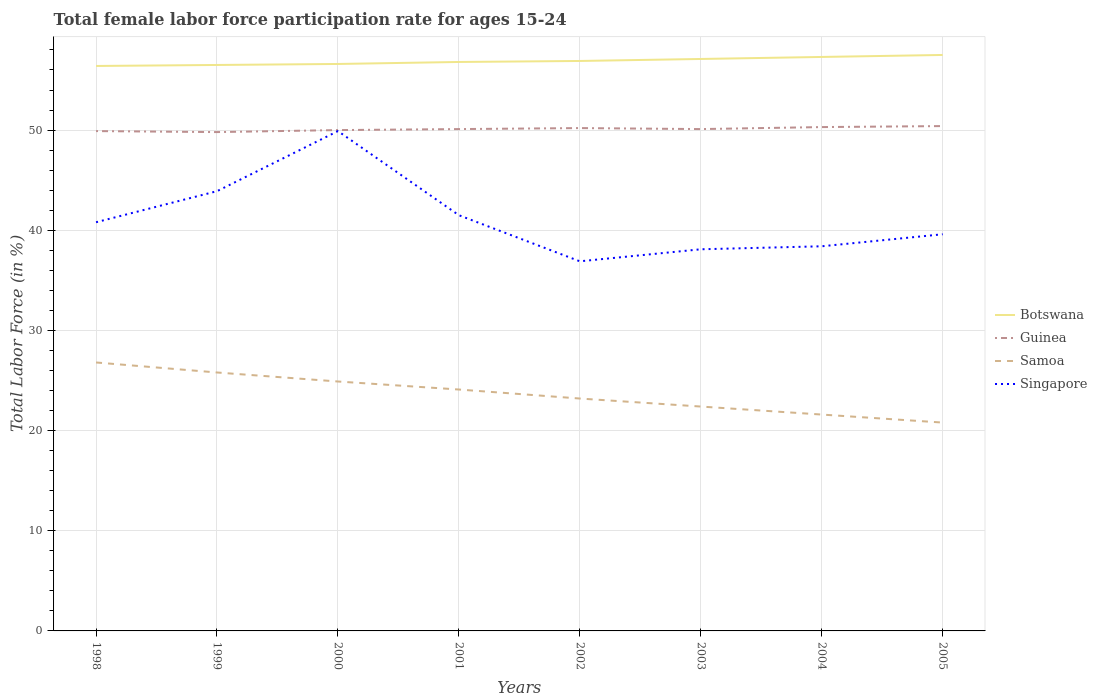Across all years, what is the maximum female labor force participation rate in Guinea?
Your answer should be very brief. 49.8. In which year was the female labor force participation rate in Singapore maximum?
Ensure brevity in your answer.  2002. What is the total female labor force participation rate in Samoa in the graph?
Keep it short and to the point. 2.7. What is the difference between the highest and the second highest female labor force participation rate in Singapore?
Ensure brevity in your answer.  13. What is the difference between the highest and the lowest female labor force participation rate in Guinea?
Keep it short and to the point. 3. Is the female labor force participation rate in Samoa strictly greater than the female labor force participation rate in Botswana over the years?
Provide a succinct answer. Yes. How many lines are there?
Provide a succinct answer. 4. How many years are there in the graph?
Ensure brevity in your answer.  8. Does the graph contain any zero values?
Offer a very short reply. No. Does the graph contain grids?
Give a very brief answer. Yes. What is the title of the graph?
Make the answer very short. Total female labor force participation rate for ages 15-24. What is the Total Labor Force (in %) of Botswana in 1998?
Your answer should be compact. 56.4. What is the Total Labor Force (in %) of Guinea in 1998?
Keep it short and to the point. 49.9. What is the Total Labor Force (in %) in Samoa in 1998?
Your answer should be compact. 26.8. What is the Total Labor Force (in %) in Singapore in 1998?
Offer a very short reply. 40.8. What is the Total Labor Force (in %) of Botswana in 1999?
Provide a short and direct response. 56.5. What is the Total Labor Force (in %) in Guinea in 1999?
Give a very brief answer. 49.8. What is the Total Labor Force (in %) in Samoa in 1999?
Keep it short and to the point. 25.8. What is the Total Labor Force (in %) of Singapore in 1999?
Provide a succinct answer. 43.9. What is the Total Labor Force (in %) in Botswana in 2000?
Provide a short and direct response. 56.6. What is the Total Labor Force (in %) of Samoa in 2000?
Your answer should be compact. 24.9. What is the Total Labor Force (in %) of Singapore in 2000?
Give a very brief answer. 49.9. What is the Total Labor Force (in %) of Botswana in 2001?
Ensure brevity in your answer.  56.8. What is the Total Labor Force (in %) in Guinea in 2001?
Keep it short and to the point. 50.1. What is the Total Labor Force (in %) in Samoa in 2001?
Your answer should be very brief. 24.1. What is the Total Labor Force (in %) in Singapore in 2001?
Make the answer very short. 41.5. What is the Total Labor Force (in %) in Botswana in 2002?
Provide a succinct answer. 56.9. What is the Total Labor Force (in %) of Guinea in 2002?
Your answer should be very brief. 50.2. What is the Total Labor Force (in %) of Samoa in 2002?
Provide a short and direct response. 23.2. What is the Total Labor Force (in %) in Singapore in 2002?
Provide a short and direct response. 36.9. What is the Total Labor Force (in %) of Botswana in 2003?
Offer a terse response. 57.1. What is the Total Labor Force (in %) in Guinea in 2003?
Your response must be concise. 50.1. What is the Total Labor Force (in %) in Samoa in 2003?
Offer a very short reply. 22.4. What is the Total Labor Force (in %) in Singapore in 2003?
Provide a short and direct response. 38.1. What is the Total Labor Force (in %) in Botswana in 2004?
Keep it short and to the point. 57.3. What is the Total Labor Force (in %) in Guinea in 2004?
Offer a very short reply. 50.3. What is the Total Labor Force (in %) in Samoa in 2004?
Ensure brevity in your answer.  21.6. What is the Total Labor Force (in %) in Singapore in 2004?
Your response must be concise. 38.4. What is the Total Labor Force (in %) of Botswana in 2005?
Your answer should be very brief. 57.5. What is the Total Labor Force (in %) in Guinea in 2005?
Offer a terse response. 50.4. What is the Total Labor Force (in %) of Samoa in 2005?
Offer a very short reply. 20.8. What is the Total Labor Force (in %) of Singapore in 2005?
Keep it short and to the point. 39.6. Across all years, what is the maximum Total Labor Force (in %) of Botswana?
Your answer should be very brief. 57.5. Across all years, what is the maximum Total Labor Force (in %) in Guinea?
Offer a very short reply. 50.4. Across all years, what is the maximum Total Labor Force (in %) of Samoa?
Make the answer very short. 26.8. Across all years, what is the maximum Total Labor Force (in %) in Singapore?
Your answer should be very brief. 49.9. Across all years, what is the minimum Total Labor Force (in %) in Botswana?
Your answer should be compact. 56.4. Across all years, what is the minimum Total Labor Force (in %) of Guinea?
Make the answer very short. 49.8. Across all years, what is the minimum Total Labor Force (in %) in Samoa?
Offer a terse response. 20.8. Across all years, what is the minimum Total Labor Force (in %) in Singapore?
Offer a terse response. 36.9. What is the total Total Labor Force (in %) of Botswana in the graph?
Offer a very short reply. 455.1. What is the total Total Labor Force (in %) in Guinea in the graph?
Your response must be concise. 400.8. What is the total Total Labor Force (in %) in Samoa in the graph?
Provide a succinct answer. 189.6. What is the total Total Labor Force (in %) in Singapore in the graph?
Make the answer very short. 329.1. What is the difference between the Total Labor Force (in %) in Botswana in 1998 and that in 1999?
Make the answer very short. -0.1. What is the difference between the Total Labor Force (in %) of Guinea in 1998 and that in 1999?
Offer a terse response. 0.1. What is the difference between the Total Labor Force (in %) in Singapore in 1998 and that in 1999?
Provide a succinct answer. -3.1. What is the difference between the Total Labor Force (in %) of Botswana in 1998 and that in 2000?
Your answer should be compact. -0.2. What is the difference between the Total Labor Force (in %) in Guinea in 1998 and that in 2000?
Make the answer very short. -0.1. What is the difference between the Total Labor Force (in %) of Guinea in 1998 and that in 2002?
Give a very brief answer. -0.3. What is the difference between the Total Labor Force (in %) in Singapore in 1998 and that in 2002?
Your response must be concise. 3.9. What is the difference between the Total Labor Force (in %) in Samoa in 1998 and that in 2003?
Offer a terse response. 4.4. What is the difference between the Total Labor Force (in %) of Guinea in 1998 and that in 2004?
Ensure brevity in your answer.  -0.4. What is the difference between the Total Labor Force (in %) in Singapore in 1998 and that in 2004?
Offer a terse response. 2.4. What is the difference between the Total Labor Force (in %) in Guinea in 1998 and that in 2005?
Make the answer very short. -0.5. What is the difference between the Total Labor Force (in %) in Guinea in 1999 and that in 2000?
Give a very brief answer. -0.2. What is the difference between the Total Labor Force (in %) of Samoa in 1999 and that in 2000?
Provide a short and direct response. 0.9. What is the difference between the Total Labor Force (in %) in Singapore in 1999 and that in 2000?
Give a very brief answer. -6. What is the difference between the Total Labor Force (in %) in Samoa in 1999 and that in 2001?
Your answer should be compact. 1.7. What is the difference between the Total Labor Force (in %) of Singapore in 1999 and that in 2001?
Give a very brief answer. 2.4. What is the difference between the Total Labor Force (in %) of Botswana in 1999 and that in 2002?
Give a very brief answer. -0.4. What is the difference between the Total Labor Force (in %) of Samoa in 1999 and that in 2002?
Offer a terse response. 2.6. What is the difference between the Total Labor Force (in %) in Botswana in 1999 and that in 2003?
Make the answer very short. -0.6. What is the difference between the Total Labor Force (in %) in Singapore in 1999 and that in 2003?
Provide a short and direct response. 5.8. What is the difference between the Total Labor Force (in %) in Guinea in 1999 and that in 2004?
Your answer should be very brief. -0.5. What is the difference between the Total Labor Force (in %) in Singapore in 1999 and that in 2004?
Ensure brevity in your answer.  5.5. What is the difference between the Total Labor Force (in %) in Guinea in 1999 and that in 2005?
Your answer should be compact. -0.6. What is the difference between the Total Labor Force (in %) in Singapore in 1999 and that in 2005?
Make the answer very short. 4.3. What is the difference between the Total Labor Force (in %) in Samoa in 2000 and that in 2001?
Make the answer very short. 0.8. What is the difference between the Total Labor Force (in %) of Botswana in 2000 and that in 2002?
Provide a short and direct response. -0.3. What is the difference between the Total Labor Force (in %) in Singapore in 2000 and that in 2002?
Offer a terse response. 13. What is the difference between the Total Labor Force (in %) in Guinea in 2000 and that in 2003?
Ensure brevity in your answer.  -0.1. What is the difference between the Total Labor Force (in %) in Samoa in 2000 and that in 2003?
Ensure brevity in your answer.  2.5. What is the difference between the Total Labor Force (in %) in Samoa in 2000 and that in 2004?
Offer a terse response. 3.3. What is the difference between the Total Labor Force (in %) in Singapore in 2000 and that in 2004?
Give a very brief answer. 11.5. What is the difference between the Total Labor Force (in %) in Botswana in 2000 and that in 2005?
Your answer should be compact. -0.9. What is the difference between the Total Labor Force (in %) in Guinea in 2000 and that in 2005?
Ensure brevity in your answer.  -0.4. What is the difference between the Total Labor Force (in %) of Samoa in 2000 and that in 2005?
Keep it short and to the point. 4.1. What is the difference between the Total Labor Force (in %) of Singapore in 2000 and that in 2005?
Your answer should be compact. 10.3. What is the difference between the Total Labor Force (in %) of Botswana in 2001 and that in 2002?
Give a very brief answer. -0.1. What is the difference between the Total Labor Force (in %) in Guinea in 2001 and that in 2002?
Your response must be concise. -0.1. What is the difference between the Total Labor Force (in %) in Botswana in 2001 and that in 2003?
Provide a succinct answer. -0.3. What is the difference between the Total Labor Force (in %) in Singapore in 2001 and that in 2003?
Ensure brevity in your answer.  3.4. What is the difference between the Total Labor Force (in %) of Guinea in 2001 and that in 2004?
Keep it short and to the point. -0.2. What is the difference between the Total Labor Force (in %) of Singapore in 2001 and that in 2004?
Ensure brevity in your answer.  3.1. What is the difference between the Total Labor Force (in %) of Singapore in 2001 and that in 2005?
Provide a short and direct response. 1.9. What is the difference between the Total Labor Force (in %) in Botswana in 2002 and that in 2003?
Provide a short and direct response. -0.2. What is the difference between the Total Labor Force (in %) of Samoa in 2002 and that in 2003?
Your response must be concise. 0.8. What is the difference between the Total Labor Force (in %) in Botswana in 2002 and that in 2004?
Your response must be concise. -0.4. What is the difference between the Total Labor Force (in %) of Guinea in 2002 and that in 2004?
Keep it short and to the point. -0.1. What is the difference between the Total Labor Force (in %) of Samoa in 2002 and that in 2004?
Provide a short and direct response. 1.6. What is the difference between the Total Labor Force (in %) of Guinea in 2002 and that in 2005?
Offer a very short reply. -0.2. What is the difference between the Total Labor Force (in %) in Singapore in 2002 and that in 2005?
Your answer should be compact. -2.7. What is the difference between the Total Labor Force (in %) of Samoa in 2003 and that in 2005?
Provide a short and direct response. 1.6. What is the difference between the Total Labor Force (in %) of Botswana in 2004 and that in 2005?
Give a very brief answer. -0.2. What is the difference between the Total Labor Force (in %) in Samoa in 2004 and that in 2005?
Ensure brevity in your answer.  0.8. What is the difference between the Total Labor Force (in %) of Botswana in 1998 and the Total Labor Force (in %) of Samoa in 1999?
Provide a short and direct response. 30.6. What is the difference between the Total Labor Force (in %) in Guinea in 1998 and the Total Labor Force (in %) in Samoa in 1999?
Make the answer very short. 24.1. What is the difference between the Total Labor Force (in %) of Samoa in 1998 and the Total Labor Force (in %) of Singapore in 1999?
Make the answer very short. -17.1. What is the difference between the Total Labor Force (in %) in Botswana in 1998 and the Total Labor Force (in %) in Guinea in 2000?
Your answer should be compact. 6.4. What is the difference between the Total Labor Force (in %) in Botswana in 1998 and the Total Labor Force (in %) in Samoa in 2000?
Your response must be concise. 31.5. What is the difference between the Total Labor Force (in %) of Botswana in 1998 and the Total Labor Force (in %) of Singapore in 2000?
Offer a very short reply. 6.5. What is the difference between the Total Labor Force (in %) in Guinea in 1998 and the Total Labor Force (in %) in Samoa in 2000?
Make the answer very short. 25. What is the difference between the Total Labor Force (in %) of Guinea in 1998 and the Total Labor Force (in %) of Singapore in 2000?
Ensure brevity in your answer.  0. What is the difference between the Total Labor Force (in %) of Samoa in 1998 and the Total Labor Force (in %) of Singapore in 2000?
Your response must be concise. -23.1. What is the difference between the Total Labor Force (in %) of Botswana in 1998 and the Total Labor Force (in %) of Samoa in 2001?
Keep it short and to the point. 32.3. What is the difference between the Total Labor Force (in %) in Botswana in 1998 and the Total Labor Force (in %) in Singapore in 2001?
Give a very brief answer. 14.9. What is the difference between the Total Labor Force (in %) in Guinea in 1998 and the Total Labor Force (in %) in Samoa in 2001?
Your answer should be very brief. 25.8. What is the difference between the Total Labor Force (in %) of Guinea in 1998 and the Total Labor Force (in %) of Singapore in 2001?
Provide a short and direct response. 8.4. What is the difference between the Total Labor Force (in %) of Samoa in 1998 and the Total Labor Force (in %) of Singapore in 2001?
Your answer should be very brief. -14.7. What is the difference between the Total Labor Force (in %) of Botswana in 1998 and the Total Labor Force (in %) of Samoa in 2002?
Ensure brevity in your answer.  33.2. What is the difference between the Total Labor Force (in %) of Guinea in 1998 and the Total Labor Force (in %) of Samoa in 2002?
Your answer should be very brief. 26.7. What is the difference between the Total Labor Force (in %) of Guinea in 1998 and the Total Labor Force (in %) of Singapore in 2002?
Keep it short and to the point. 13. What is the difference between the Total Labor Force (in %) in Samoa in 1998 and the Total Labor Force (in %) in Singapore in 2002?
Offer a terse response. -10.1. What is the difference between the Total Labor Force (in %) in Botswana in 1998 and the Total Labor Force (in %) in Guinea in 2003?
Keep it short and to the point. 6.3. What is the difference between the Total Labor Force (in %) in Botswana in 1998 and the Total Labor Force (in %) in Samoa in 2003?
Provide a short and direct response. 34. What is the difference between the Total Labor Force (in %) in Guinea in 1998 and the Total Labor Force (in %) in Samoa in 2003?
Your answer should be compact. 27.5. What is the difference between the Total Labor Force (in %) in Guinea in 1998 and the Total Labor Force (in %) in Singapore in 2003?
Ensure brevity in your answer.  11.8. What is the difference between the Total Labor Force (in %) in Samoa in 1998 and the Total Labor Force (in %) in Singapore in 2003?
Offer a terse response. -11.3. What is the difference between the Total Labor Force (in %) in Botswana in 1998 and the Total Labor Force (in %) in Samoa in 2004?
Your answer should be compact. 34.8. What is the difference between the Total Labor Force (in %) of Guinea in 1998 and the Total Labor Force (in %) of Samoa in 2004?
Provide a succinct answer. 28.3. What is the difference between the Total Labor Force (in %) of Guinea in 1998 and the Total Labor Force (in %) of Singapore in 2004?
Your answer should be very brief. 11.5. What is the difference between the Total Labor Force (in %) of Botswana in 1998 and the Total Labor Force (in %) of Guinea in 2005?
Ensure brevity in your answer.  6. What is the difference between the Total Labor Force (in %) in Botswana in 1998 and the Total Labor Force (in %) in Samoa in 2005?
Keep it short and to the point. 35.6. What is the difference between the Total Labor Force (in %) of Botswana in 1998 and the Total Labor Force (in %) of Singapore in 2005?
Offer a terse response. 16.8. What is the difference between the Total Labor Force (in %) in Guinea in 1998 and the Total Labor Force (in %) in Samoa in 2005?
Give a very brief answer. 29.1. What is the difference between the Total Labor Force (in %) of Botswana in 1999 and the Total Labor Force (in %) of Samoa in 2000?
Offer a terse response. 31.6. What is the difference between the Total Labor Force (in %) of Botswana in 1999 and the Total Labor Force (in %) of Singapore in 2000?
Your answer should be very brief. 6.6. What is the difference between the Total Labor Force (in %) in Guinea in 1999 and the Total Labor Force (in %) in Samoa in 2000?
Offer a very short reply. 24.9. What is the difference between the Total Labor Force (in %) of Guinea in 1999 and the Total Labor Force (in %) of Singapore in 2000?
Provide a short and direct response. -0.1. What is the difference between the Total Labor Force (in %) of Samoa in 1999 and the Total Labor Force (in %) of Singapore in 2000?
Offer a very short reply. -24.1. What is the difference between the Total Labor Force (in %) in Botswana in 1999 and the Total Labor Force (in %) in Guinea in 2001?
Offer a very short reply. 6.4. What is the difference between the Total Labor Force (in %) in Botswana in 1999 and the Total Labor Force (in %) in Samoa in 2001?
Your response must be concise. 32.4. What is the difference between the Total Labor Force (in %) in Botswana in 1999 and the Total Labor Force (in %) in Singapore in 2001?
Give a very brief answer. 15. What is the difference between the Total Labor Force (in %) in Guinea in 1999 and the Total Labor Force (in %) in Samoa in 2001?
Your answer should be very brief. 25.7. What is the difference between the Total Labor Force (in %) of Guinea in 1999 and the Total Labor Force (in %) of Singapore in 2001?
Offer a very short reply. 8.3. What is the difference between the Total Labor Force (in %) in Samoa in 1999 and the Total Labor Force (in %) in Singapore in 2001?
Ensure brevity in your answer.  -15.7. What is the difference between the Total Labor Force (in %) in Botswana in 1999 and the Total Labor Force (in %) in Samoa in 2002?
Provide a short and direct response. 33.3. What is the difference between the Total Labor Force (in %) in Botswana in 1999 and the Total Labor Force (in %) in Singapore in 2002?
Offer a terse response. 19.6. What is the difference between the Total Labor Force (in %) of Guinea in 1999 and the Total Labor Force (in %) of Samoa in 2002?
Give a very brief answer. 26.6. What is the difference between the Total Labor Force (in %) in Samoa in 1999 and the Total Labor Force (in %) in Singapore in 2002?
Offer a terse response. -11.1. What is the difference between the Total Labor Force (in %) in Botswana in 1999 and the Total Labor Force (in %) in Samoa in 2003?
Offer a very short reply. 34.1. What is the difference between the Total Labor Force (in %) in Guinea in 1999 and the Total Labor Force (in %) in Samoa in 2003?
Give a very brief answer. 27.4. What is the difference between the Total Labor Force (in %) in Guinea in 1999 and the Total Labor Force (in %) in Singapore in 2003?
Make the answer very short. 11.7. What is the difference between the Total Labor Force (in %) of Botswana in 1999 and the Total Labor Force (in %) of Guinea in 2004?
Your answer should be compact. 6.2. What is the difference between the Total Labor Force (in %) of Botswana in 1999 and the Total Labor Force (in %) of Samoa in 2004?
Keep it short and to the point. 34.9. What is the difference between the Total Labor Force (in %) in Guinea in 1999 and the Total Labor Force (in %) in Samoa in 2004?
Your answer should be compact. 28.2. What is the difference between the Total Labor Force (in %) of Botswana in 1999 and the Total Labor Force (in %) of Guinea in 2005?
Your answer should be very brief. 6.1. What is the difference between the Total Labor Force (in %) of Botswana in 1999 and the Total Labor Force (in %) of Samoa in 2005?
Provide a short and direct response. 35.7. What is the difference between the Total Labor Force (in %) in Guinea in 1999 and the Total Labor Force (in %) in Samoa in 2005?
Offer a very short reply. 29. What is the difference between the Total Labor Force (in %) in Botswana in 2000 and the Total Labor Force (in %) in Guinea in 2001?
Provide a succinct answer. 6.5. What is the difference between the Total Labor Force (in %) of Botswana in 2000 and the Total Labor Force (in %) of Samoa in 2001?
Keep it short and to the point. 32.5. What is the difference between the Total Labor Force (in %) of Guinea in 2000 and the Total Labor Force (in %) of Samoa in 2001?
Give a very brief answer. 25.9. What is the difference between the Total Labor Force (in %) in Guinea in 2000 and the Total Labor Force (in %) in Singapore in 2001?
Offer a very short reply. 8.5. What is the difference between the Total Labor Force (in %) in Samoa in 2000 and the Total Labor Force (in %) in Singapore in 2001?
Ensure brevity in your answer.  -16.6. What is the difference between the Total Labor Force (in %) of Botswana in 2000 and the Total Labor Force (in %) of Samoa in 2002?
Ensure brevity in your answer.  33.4. What is the difference between the Total Labor Force (in %) of Botswana in 2000 and the Total Labor Force (in %) of Singapore in 2002?
Your answer should be compact. 19.7. What is the difference between the Total Labor Force (in %) in Guinea in 2000 and the Total Labor Force (in %) in Samoa in 2002?
Your answer should be compact. 26.8. What is the difference between the Total Labor Force (in %) in Guinea in 2000 and the Total Labor Force (in %) in Singapore in 2002?
Your response must be concise. 13.1. What is the difference between the Total Labor Force (in %) of Samoa in 2000 and the Total Labor Force (in %) of Singapore in 2002?
Your answer should be very brief. -12. What is the difference between the Total Labor Force (in %) of Botswana in 2000 and the Total Labor Force (in %) of Samoa in 2003?
Your answer should be compact. 34.2. What is the difference between the Total Labor Force (in %) in Guinea in 2000 and the Total Labor Force (in %) in Samoa in 2003?
Give a very brief answer. 27.6. What is the difference between the Total Labor Force (in %) of Botswana in 2000 and the Total Labor Force (in %) of Guinea in 2004?
Offer a terse response. 6.3. What is the difference between the Total Labor Force (in %) of Botswana in 2000 and the Total Labor Force (in %) of Singapore in 2004?
Offer a very short reply. 18.2. What is the difference between the Total Labor Force (in %) of Guinea in 2000 and the Total Labor Force (in %) of Samoa in 2004?
Provide a short and direct response. 28.4. What is the difference between the Total Labor Force (in %) in Guinea in 2000 and the Total Labor Force (in %) in Singapore in 2004?
Make the answer very short. 11.6. What is the difference between the Total Labor Force (in %) in Samoa in 2000 and the Total Labor Force (in %) in Singapore in 2004?
Your answer should be compact. -13.5. What is the difference between the Total Labor Force (in %) of Botswana in 2000 and the Total Labor Force (in %) of Guinea in 2005?
Ensure brevity in your answer.  6.2. What is the difference between the Total Labor Force (in %) of Botswana in 2000 and the Total Labor Force (in %) of Samoa in 2005?
Make the answer very short. 35.8. What is the difference between the Total Labor Force (in %) of Botswana in 2000 and the Total Labor Force (in %) of Singapore in 2005?
Your answer should be very brief. 17. What is the difference between the Total Labor Force (in %) in Guinea in 2000 and the Total Labor Force (in %) in Samoa in 2005?
Offer a terse response. 29.2. What is the difference between the Total Labor Force (in %) in Guinea in 2000 and the Total Labor Force (in %) in Singapore in 2005?
Offer a terse response. 10.4. What is the difference between the Total Labor Force (in %) in Samoa in 2000 and the Total Labor Force (in %) in Singapore in 2005?
Your response must be concise. -14.7. What is the difference between the Total Labor Force (in %) of Botswana in 2001 and the Total Labor Force (in %) of Guinea in 2002?
Offer a very short reply. 6.6. What is the difference between the Total Labor Force (in %) in Botswana in 2001 and the Total Labor Force (in %) in Samoa in 2002?
Ensure brevity in your answer.  33.6. What is the difference between the Total Labor Force (in %) in Guinea in 2001 and the Total Labor Force (in %) in Samoa in 2002?
Offer a very short reply. 26.9. What is the difference between the Total Labor Force (in %) of Guinea in 2001 and the Total Labor Force (in %) of Singapore in 2002?
Provide a succinct answer. 13.2. What is the difference between the Total Labor Force (in %) in Botswana in 2001 and the Total Labor Force (in %) in Guinea in 2003?
Your answer should be very brief. 6.7. What is the difference between the Total Labor Force (in %) in Botswana in 2001 and the Total Labor Force (in %) in Samoa in 2003?
Provide a succinct answer. 34.4. What is the difference between the Total Labor Force (in %) in Guinea in 2001 and the Total Labor Force (in %) in Samoa in 2003?
Offer a terse response. 27.7. What is the difference between the Total Labor Force (in %) in Guinea in 2001 and the Total Labor Force (in %) in Singapore in 2003?
Provide a succinct answer. 12. What is the difference between the Total Labor Force (in %) in Samoa in 2001 and the Total Labor Force (in %) in Singapore in 2003?
Provide a short and direct response. -14. What is the difference between the Total Labor Force (in %) of Botswana in 2001 and the Total Labor Force (in %) of Guinea in 2004?
Offer a terse response. 6.5. What is the difference between the Total Labor Force (in %) of Botswana in 2001 and the Total Labor Force (in %) of Samoa in 2004?
Provide a short and direct response. 35.2. What is the difference between the Total Labor Force (in %) of Guinea in 2001 and the Total Labor Force (in %) of Samoa in 2004?
Keep it short and to the point. 28.5. What is the difference between the Total Labor Force (in %) of Samoa in 2001 and the Total Labor Force (in %) of Singapore in 2004?
Give a very brief answer. -14.3. What is the difference between the Total Labor Force (in %) in Botswana in 2001 and the Total Labor Force (in %) in Samoa in 2005?
Ensure brevity in your answer.  36. What is the difference between the Total Labor Force (in %) of Guinea in 2001 and the Total Labor Force (in %) of Samoa in 2005?
Give a very brief answer. 29.3. What is the difference between the Total Labor Force (in %) in Guinea in 2001 and the Total Labor Force (in %) in Singapore in 2005?
Provide a short and direct response. 10.5. What is the difference between the Total Labor Force (in %) in Samoa in 2001 and the Total Labor Force (in %) in Singapore in 2005?
Keep it short and to the point. -15.5. What is the difference between the Total Labor Force (in %) in Botswana in 2002 and the Total Labor Force (in %) in Samoa in 2003?
Keep it short and to the point. 34.5. What is the difference between the Total Labor Force (in %) in Botswana in 2002 and the Total Labor Force (in %) in Singapore in 2003?
Offer a very short reply. 18.8. What is the difference between the Total Labor Force (in %) in Guinea in 2002 and the Total Labor Force (in %) in Samoa in 2003?
Your response must be concise. 27.8. What is the difference between the Total Labor Force (in %) of Samoa in 2002 and the Total Labor Force (in %) of Singapore in 2003?
Offer a very short reply. -14.9. What is the difference between the Total Labor Force (in %) in Botswana in 2002 and the Total Labor Force (in %) in Samoa in 2004?
Offer a terse response. 35.3. What is the difference between the Total Labor Force (in %) of Botswana in 2002 and the Total Labor Force (in %) of Singapore in 2004?
Offer a terse response. 18.5. What is the difference between the Total Labor Force (in %) in Guinea in 2002 and the Total Labor Force (in %) in Samoa in 2004?
Give a very brief answer. 28.6. What is the difference between the Total Labor Force (in %) of Guinea in 2002 and the Total Labor Force (in %) of Singapore in 2004?
Keep it short and to the point. 11.8. What is the difference between the Total Labor Force (in %) in Samoa in 2002 and the Total Labor Force (in %) in Singapore in 2004?
Make the answer very short. -15.2. What is the difference between the Total Labor Force (in %) in Botswana in 2002 and the Total Labor Force (in %) in Guinea in 2005?
Ensure brevity in your answer.  6.5. What is the difference between the Total Labor Force (in %) of Botswana in 2002 and the Total Labor Force (in %) of Samoa in 2005?
Your answer should be very brief. 36.1. What is the difference between the Total Labor Force (in %) in Botswana in 2002 and the Total Labor Force (in %) in Singapore in 2005?
Offer a terse response. 17.3. What is the difference between the Total Labor Force (in %) of Guinea in 2002 and the Total Labor Force (in %) of Samoa in 2005?
Ensure brevity in your answer.  29.4. What is the difference between the Total Labor Force (in %) in Samoa in 2002 and the Total Labor Force (in %) in Singapore in 2005?
Offer a terse response. -16.4. What is the difference between the Total Labor Force (in %) in Botswana in 2003 and the Total Labor Force (in %) in Guinea in 2004?
Keep it short and to the point. 6.8. What is the difference between the Total Labor Force (in %) of Botswana in 2003 and the Total Labor Force (in %) of Samoa in 2004?
Your answer should be very brief. 35.5. What is the difference between the Total Labor Force (in %) in Botswana in 2003 and the Total Labor Force (in %) in Singapore in 2004?
Offer a terse response. 18.7. What is the difference between the Total Labor Force (in %) of Guinea in 2003 and the Total Labor Force (in %) of Samoa in 2004?
Your response must be concise. 28.5. What is the difference between the Total Labor Force (in %) in Samoa in 2003 and the Total Labor Force (in %) in Singapore in 2004?
Provide a short and direct response. -16. What is the difference between the Total Labor Force (in %) in Botswana in 2003 and the Total Labor Force (in %) in Samoa in 2005?
Your answer should be compact. 36.3. What is the difference between the Total Labor Force (in %) in Botswana in 2003 and the Total Labor Force (in %) in Singapore in 2005?
Keep it short and to the point. 17.5. What is the difference between the Total Labor Force (in %) in Guinea in 2003 and the Total Labor Force (in %) in Samoa in 2005?
Keep it short and to the point. 29.3. What is the difference between the Total Labor Force (in %) of Samoa in 2003 and the Total Labor Force (in %) of Singapore in 2005?
Provide a short and direct response. -17.2. What is the difference between the Total Labor Force (in %) in Botswana in 2004 and the Total Labor Force (in %) in Samoa in 2005?
Ensure brevity in your answer.  36.5. What is the difference between the Total Labor Force (in %) of Guinea in 2004 and the Total Labor Force (in %) of Samoa in 2005?
Your answer should be compact. 29.5. What is the difference between the Total Labor Force (in %) in Guinea in 2004 and the Total Labor Force (in %) in Singapore in 2005?
Make the answer very short. 10.7. What is the average Total Labor Force (in %) of Botswana per year?
Keep it short and to the point. 56.89. What is the average Total Labor Force (in %) of Guinea per year?
Ensure brevity in your answer.  50.1. What is the average Total Labor Force (in %) in Samoa per year?
Offer a terse response. 23.7. What is the average Total Labor Force (in %) of Singapore per year?
Ensure brevity in your answer.  41.14. In the year 1998, what is the difference between the Total Labor Force (in %) of Botswana and Total Labor Force (in %) of Samoa?
Ensure brevity in your answer.  29.6. In the year 1998, what is the difference between the Total Labor Force (in %) of Guinea and Total Labor Force (in %) of Samoa?
Provide a short and direct response. 23.1. In the year 1998, what is the difference between the Total Labor Force (in %) of Guinea and Total Labor Force (in %) of Singapore?
Offer a very short reply. 9.1. In the year 1999, what is the difference between the Total Labor Force (in %) of Botswana and Total Labor Force (in %) of Samoa?
Keep it short and to the point. 30.7. In the year 1999, what is the difference between the Total Labor Force (in %) of Botswana and Total Labor Force (in %) of Singapore?
Provide a short and direct response. 12.6. In the year 1999, what is the difference between the Total Labor Force (in %) in Samoa and Total Labor Force (in %) in Singapore?
Provide a succinct answer. -18.1. In the year 2000, what is the difference between the Total Labor Force (in %) of Botswana and Total Labor Force (in %) of Guinea?
Offer a terse response. 6.6. In the year 2000, what is the difference between the Total Labor Force (in %) in Botswana and Total Labor Force (in %) in Samoa?
Keep it short and to the point. 31.7. In the year 2000, what is the difference between the Total Labor Force (in %) of Botswana and Total Labor Force (in %) of Singapore?
Ensure brevity in your answer.  6.7. In the year 2000, what is the difference between the Total Labor Force (in %) in Guinea and Total Labor Force (in %) in Samoa?
Offer a terse response. 25.1. In the year 2000, what is the difference between the Total Labor Force (in %) in Samoa and Total Labor Force (in %) in Singapore?
Keep it short and to the point. -25. In the year 2001, what is the difference between the Total Labor Force (in %) of Botswana and Total Labor Force (in %) of Samoa?
Offer a very short reply. 32.7. In the year 2001, what is the difference between the Total Labor Force (in %) in Samoa and Total Labor Force (in %) in Singapore?
Keep it short and to the point. -17.4. In the year 2002, what is the difference between the Total Labor Force (in %) in Botswana and Total Labor Force (in %) in Guinea?
Your answer should be compact. 6.7. In the year 2002, what is the difference between the Total Labor Force (in %) in Botswana and Total Labor Force (in %) in Samoa?
Offer a very short reply. 33.7. In the year 2002, what is the difference between the Total Labor Force (in %) of Botswana and Total Labor Force (in %) of Singapore?
Give a very brief answer. 20. In the year 2002, what is the difference between the Total Labor Force (in %) of Samoa and Total Labor Force (in %) of Singapore?
Keep it short and to the point. -13.7. In the year 2003, what is the difference between the Total Labor Force (in %) of Botswana and Total Labor Force (in %) of Samoa?
Keep it short and to the point. 34.7. In the year 2003, what is the difference between the Total Labor Force (in %) in Guinea and Total Labor Force (in %) in Samoa?
Your answer should be very brief. 27.7. In the year 2003, what is the difference between the Total Labor Force (in %) in Guinea and Total Labor Force (in %) in Singapore?
Provide a succinct answer. 12. In the year 2003, what is the difference between the Total Labor Force (in %) in Samoa and Total Labor Force (in %) in Singapore?
Your answer should be compact. -15.7. In the year 2004, what is the difference between the Total Labor Force (in %) of Botswana and Total Labor Force (in %) of Guinea?
Provide a short and direct response. 7. In the year 2004, what is the difference between the Total Labor Force (in %) in Botswana and Total Labor Force (in %) in Samoa?
Your answer should be very brief. 35.7. In the year 2004, what is the difference between the Total Labor Force (in %) of Botswana and Total Labor Force (in %) of Singapore?
Your response must be concise. 18.9. In the year 2004, what is the difference between the Total Labor Force (in %) in Guinea and Total Labor Force (in %) in Samoa?
Offer a terse response. 28.7. In the year 2004, what is the difference between the Total Labor Force (in %) in Samoa and Total Labor Force (in %) in Singapore?
Give a very brief answer. -16.8. In the year 2005, what is the difference between the Total Labor Force (in %) in Botswana and Total Labor Force (in %) in Samoa?
Ensure brevity in your answer.  36.7. In the year 2005, what is the difference between the Total Labor Force (in %) in Guinea and Total Labor Force (in %) in Samoa?
Keep it short and to the point. 29.6. In the year 2005, what is the difference between the Total Labor Force (in %) of Samoa and Total Labor Force (in %) of Singapore?
Ensure brevity in your answer.  -18.8. What is the ratio of the Total Labor Force (in %) in Botswana in 1998 to that in 1999?
Make the answer very short. 1. What is the ratio of the Total Labor Force (in %) of Samoa in 1998 to that in 1999?
Make the answer very short. 1.04. What is the ratio of the Total Labor Force (in %) of Singapore in 1998 to that in 1999?
Keep it short and to the point. 0.93. What is the ratio of the Total Labor Force (in %) of Botswana in 1998 to that in 2000?
Your response must be concise. 1. What is the ratio of the Total Labor Force (in %) in Samoa in 1998 to that in 2000?
Your answer should be very brief. 1.08. What is the ratio of the Total Labor Force (in %) in Singapore in 1998 to that in 2000?
Provide a short and direct response. 0.82. What is the ratio of the Total Labor Force (in %) of Botswana in 1998 to that in 2001?
Your answer should be compact. 0.99. What is the ratio of the Total Labor Force (in %) of Guinea in 1998 to that in 2001?
Your answer should be compact. 1. What is the ratio of the Total Labor Force (in %) in Samoa in 1998 to that in 2001?
Offer a terse response. 1.11. What is the ratio of the Total Labor Force (in %) in Singapore in 1998 to that in 2001?
Ensure brevity in your answer.  0.98. What is the ratio of the Total Labor Force (in %) in Botswana in 1998 to that in 2002?
Make the answer very short. 0.99. What is the ratio of the Total Labor Force (in %) in Samoa in 1998 to that in 2002?
Offer a terse response. 1.16. What is the ratio of the Total Labor Force (in %) of Singapore in 1998 to that in 2002?
Give a very brief answer. 1.11. What is the ratio of the Total Labor Force (in %) in Botswana in 1998 to that in 2003?
Your answer should be very brief. 0.99. What is the ratio of the Total Labor Force (in %) in Guinea in 1998 to that in 2003?
Ensure brevity in your answer.  1. What is the ratio of the Total Labor Force (in %) of Samoa in 1998 to that in 2003?
Give a very brief answer. 1.2. What is the ratio of the Total Labor Force (in %) in Singapore in 1998 to that in 2003?
Make the answer very short. 1.07. What is the ratio of the Total Labor Force (in %) of Botswana in 1998 to that in 2004?
Your answer should be very brief. 0.98. What is the ratio of the Total Labor Force (in %) in Samoa in 1998 to that in 2004?
Give a very brief answer. 1.24. What is the ratio of the Total Labor Force (in %) in Botswana in 1998 to that in 2005?
Keep it short and to the point. 0.98. What is the ratio of the Total Labor Force (in %) of Samoa in 1998 to that in 2005?
Your answer should be very brief. 1.29. What is the ratio of the Total Labor Force (in %) of Singapore in 1998 to that in 2005?
Offer a terse response. 1.03. What is the ratio of the Total Labor Force (in %) in Botswana in 1999 to that in 2000?
Your response must be concise. 1. What is the ratio of the Total Labor Force (in %) of Guinea in 1999 to that in 2000?
Offer a very short reply. 1. What is the ratio of the Total Labor Force (in %) of Samoa in 1999 to that in 2000?
Your response must be concise. 1.04. What is the ratio of the Total Labor Force (in %) in Singapore in 1999 to that in 2000?
Give a very brief answer. 0.88. What is the ratio of the Total Labor Force (in %) in Samoa in 1999 to that in 2001?
Make the answer very short. 1.07. What is the ratio of the Total Labor Force (in %) in Singapore in 1999 to that in 2001?
Ensure brevity in your answer.  1.06. What is the ratio of the Total Labor Force (in %) in Guinea in 1999 to that in 2002?
Provide a succinct answer. 0.99. What is the ratio of the Total Labor Force (in %) of Samoa in 1999 to that in 2002?
Offer a terse response. 1.11. What is the ratio of the Total Labor Force (in %) in Singapore in 1999 to that in 2002?
Your response must be concise. 1.19. What is the ratio of the Total Labor Force (in %) of Botswana in 1999 to that in 2003?
Your response must be concise. 0.99. What is the ratio of the Total Labor Force (in %) in Guinea in 1999 to that in 2003?
Give a very brief answer. 0.99. What is the ratio of the Total Labor Force (in %) in Samoa in 1999 to that in 2003?
Offer a very short reply. 1.15. What is the ratio of the Total Labor Force (in %) in Singapore in 1999 to that in 2003?
Offer a terse response. 1.15. What is the ratio of the Total Labor Force (in %) in Samoa in 1999 to that in 2004?
Your answer should be compact. 1.19. What is the ratio of the Total Labor Force (in %) in Singapore in 1999 to that in 2004?
Offer a very short reply. 1.14. What is the ratio of the Total Labor Force (in %) of Botswana in 1999 to that in 2005?
Keep it short and to the point. 0.98. What is the ratio of the Total Labor Force (in %) in Guinea in 1999 to that in 2005?
Give a very brief answer. 0.99. What is the ratio of the Total Labor Force (in %) in Samoa in 1999 to that in 2005?
Your answer should be compact. 1.24. What is the ratio of the Total Labor Force (in %) in Singapore in 1999 to that in 2005?
Provide a succinct answer. 1.11. What is the ratio of the Total Labor Force (in %) of Samoa in 2000 to that in 2001?
Your response must be concise. 1.03. What is the ratio of the Total Labor Force (in %) in Singapore in 2000 to that in 2001?
Provide a short and direct response. 1.2. What is the ratio of the Total Labor Force (in %) of Botswana in 2000 to that in 2002?
Offer a very short reply. 0.99. What is the ratio of the Total Labor Force (in %) of Samoa in 2000 to that in 2002?
Your response must be concise. 1.07. What is the ratio of the Total Labor Force (in %) of Singapore in 2000 to that in 2002?
Keep it short and to the point. 1.35. What is the ratio of the Total Labor Force (in %) in Botswana in 2000 to that in 2003?
Offer a very short reply. 0.99. What is the ratio of the Total Labor Force (in %) in Samoa in 2000 to that in 2003?
Offer a terse response. 1.11. What is the ratio of the Total Labor Force (in %) in Singapore in 2000 to that in 2003?
Keep it short and to the point. 1.31. What is the ratio of the Total Labor Force (in %) in Guinea in 2000 to that in 2004?
Offer a very short reply. 0.99. What is the ratio of the Total Labor Force (in %) in Samoa in 2000 to that in 2004?
Offer a terse response. 1.15. What is the ratio of the Total Labor Force (in %) of Singapore in 2000 to that in 2004?
Keep it short and to the point. 1.3. What is the ratio of the Total Labor Force (in %) in Botswana in 2000 to that in 2005?
Provide a succinct answer. 0.98. What is the ratio of the Total Labor Force (in %) of Samoa in 2000 to that in 2005?
Give a very brief answer. 1.2. What is the ratio of the Total Labor Force (in %) of Singapore in 2000 to that in 2005?
Offer a terse response. 1.26. What is the ratio of the Total Labor Force (in %) of Botswana in 2001 to that in 2002?
Offer a very short reply. 1. What is the ratio of the Total Labor Force (in %) in Samoa in 2001 to that in 2002?
Provide a short and direct response. 1.04. What is the ratio of the Total Labor Force (in %) in Singapore in 2001 to that in 2002?
Keep it short and to the point. 1.12. What is the ratio of the Total Labor Force (in %) in Samoa in 2001 to that in 2003?
Provide a succinct answer. 1.08. What is the ratio of the Total Labor Force (in %) in Singapore in 2001 to that in 2003?
Provide a short and direct response. 1.09. What is the ratio of the Total Labor Force (in %) in Botswana in 2001 to that in 2004?
Keep it short and to the point. 0.99. What is the ratio of the Total Labor Force (in %) in Samoa in 2001 to that in 2004?
Keep it short and to the point. 1.12. What is the ratio of the Total Labor Force (in %) in Singapore in 2001 to that in 2004?
Offer a terse response. 1.08. What is the ratio of the Total Labor Force (in %) of Guinea in 2001 to that in 2005?
Give a very brief answer. 0.99. What is the ratio of the Total Labor Force (in %) in Samoa in 2001 to that in 2005?
Offer a very short reply. 1.16. What is the ratio of the Total Labor Force (in %) of Singapore in 2001 to that in 2005?
Provide a short and direct response. 1.05. What is the ratio of the Total Labor Force (in %) in Botswana in 2002 to that in 2003?
Keep it short and to the point. 1. What is the ratio of the Total Labor Force (in %) in Guinea in 2002 to that in 2003?
Offer a terse response. 1. What is the ratio of the Total Labor Force (in %) of Samoa in 2002 to that in 2003?
Provide a short and direct response. 1.04. What is the ratio of the Total Labor Force (in %) in Singapore in 2002 to that in 2003?
Keep it short and to the point. 0.97. What is the ratio of the Total Labor Force (in %) of Botswana in 2002 to that in 2004?
Your response must be concise. 0.99. What is the ratio of the Total Labor Force (in %) in Guinea in 2002 to that in 2004?
Your response must be concise. 1. What is the ratio of the Total Labor Force (in %) of Samoa in 2002 to that in 2004?
Provide a short and direct response. 1.07. What is the ratio of the Total Labor Force (in %) of Singapore in 2002 to that in 2004?
Your answer should be very brief. 0.96. What is the ratio of the Total Labor Force (in %) in Botswana in 2002 to that in 2005?
Provide a short and direct response. 0.99. What is the ratio of the Total Labor Force (in %) of Guinea in 2002 to that in 2005?
Provide a succinct answer. 1. What is the ratio of the Total Labor Force (in %) in Samoa in 2002 to that in 2005?
Make the answer very short. 1.12. What is the ratio of the Total Labor Force (in %) of Singapore in 2002 to that in 2005?
Your answer should be compact. 0.93. What is the ratio of the Total Labor Force (in %) in Guinea in 2003 to that in 2004?
Offer a very short reply. 1. What is the ratio of the Total Labor Force (in %) in Samoa in 2003 to that in 2004?
Your answer should be very brief. 1.04. What is the ratio of the Total Labor Force (in %) in Singapore in 2003 to that in 2004?
Keep it short and to the point. 0.99. What is the ratio of the Total Labor Force (in %) of Botswana in 2003 to that in 2005?
Offer a very short reply. 0.99. What is the ratio of the Total Labor Force (in %) of Singapore in 2003 to that in 2005?
Offer a very short reply. 0.96. What is the ratio of the Total Labor Force (in %) in Guinea in 2004 to that in 2005?
Your answer should be compact. 1. What is the ratio of the Total Labor Force (in %) in Singapore in 2004 to that in 2005?
Offer a very short reply. 0.97. What is the difference between the highest and the second highest Total Labor Force (in %) of Botswana?
Provide a short and direct response. 0.2. What is the difference between the highest and the second highest Total Labor Force (in %) of Guinea?
Your answer should be compact. 0.1. What is the difference between the highest and the second highest Total Labor Force (in %) of Singapore?
Make the answer very short. 6. What is the difference between the highest and the lowest Total Labor Force (in %) in Samoa?
Offer a terse response. 6. What is the difference between the highest and the lowest Total Labor Force (in %) of Singapore?
Give a very brief answer. 13. 